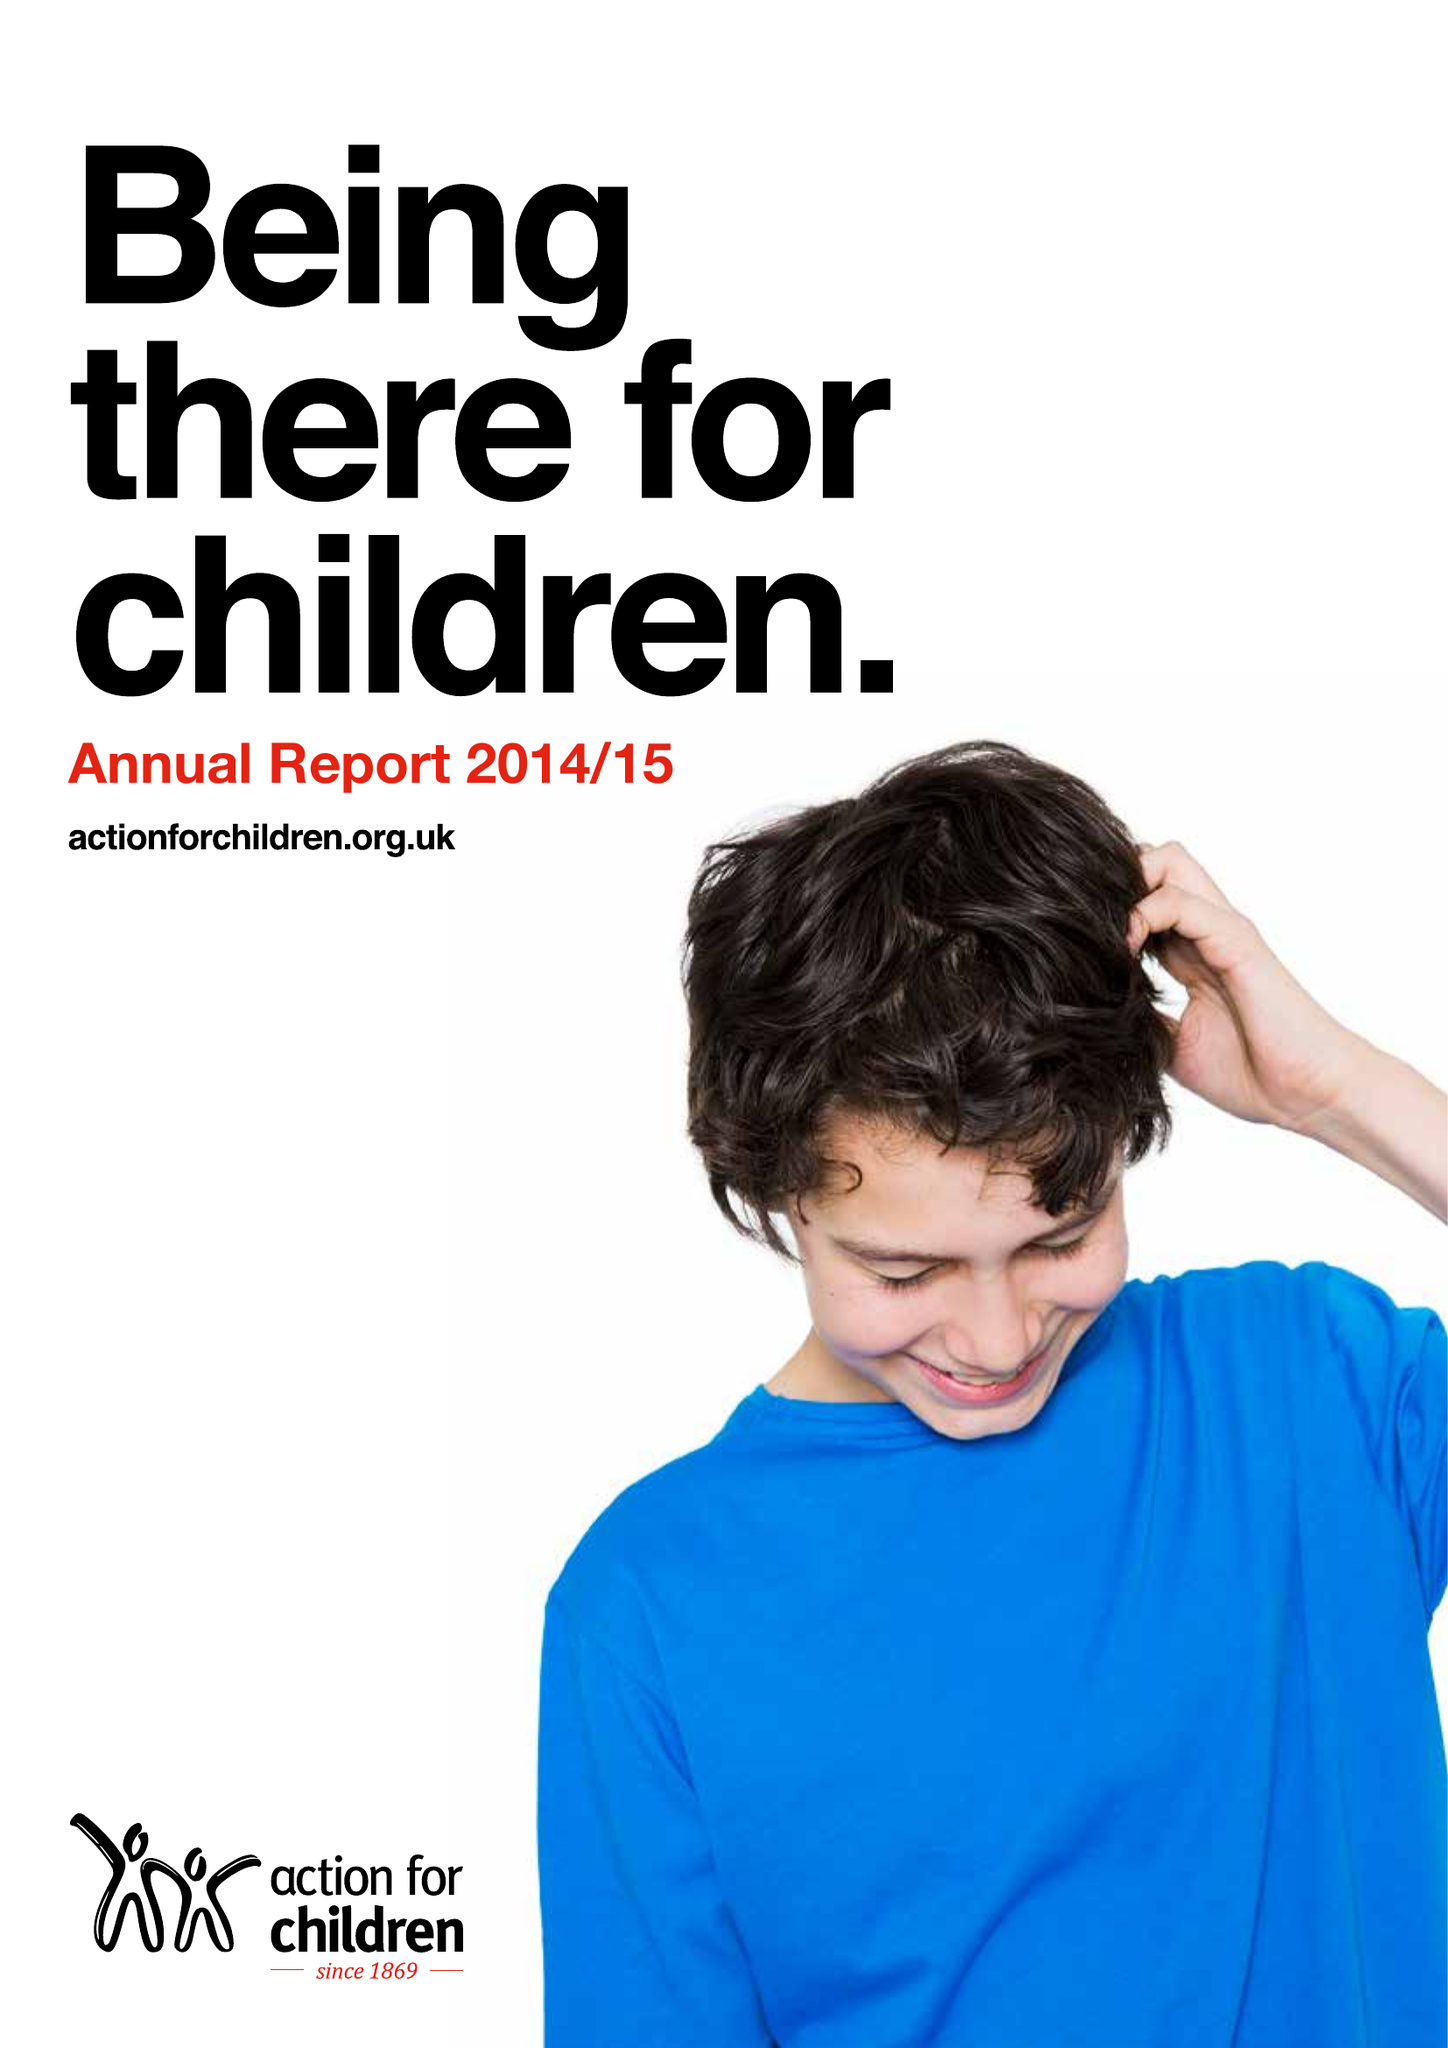What is the value for the address__street_line?
Answer the question using a single word or phrase. ASCOT ROAD 